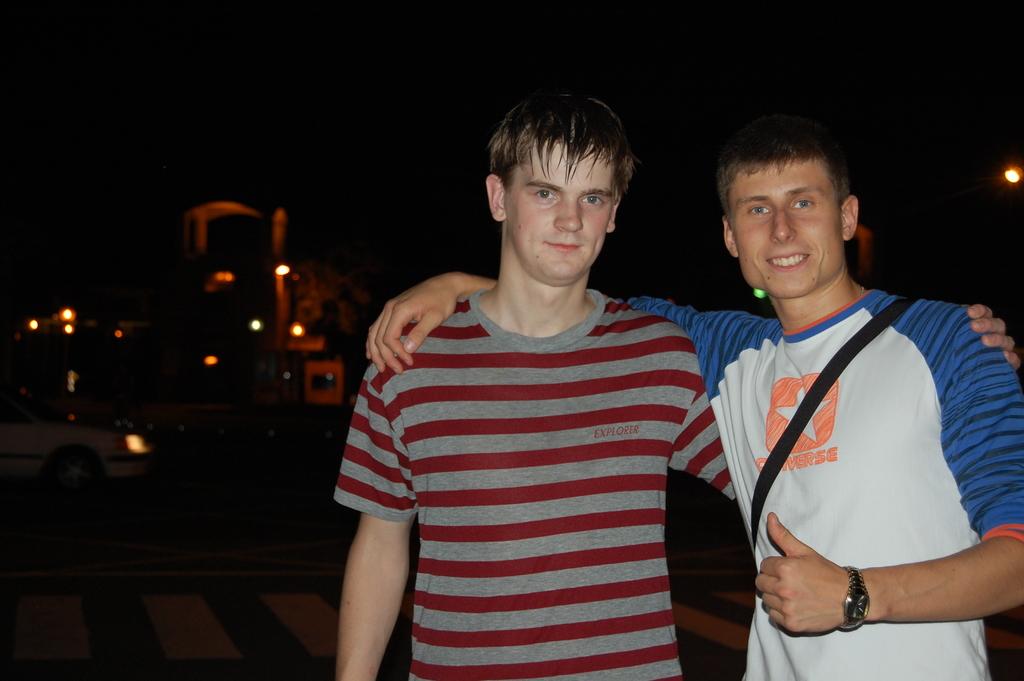What brand of t-shirt is the one on the right?
Give a very brief answer. Converse. 